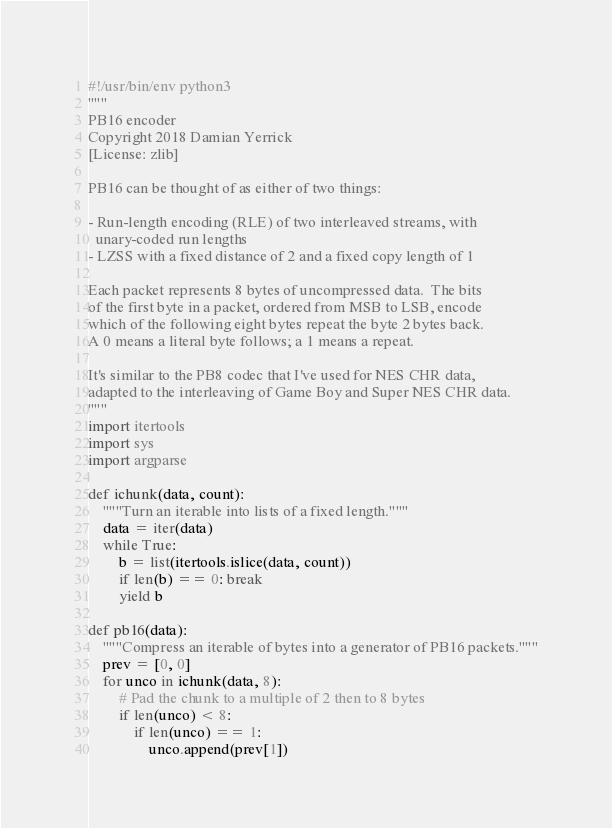<code> <loc_0><loc_0><loc_500><loc_500><_Python_>#!/usr/bin/env python3
"""
PB16 encoder
Copyright 2018 Damian Yerrick
[License: zlib]

PB16 can be thought of as either of two things:

- Run-length encoding (RLE) of two interleaved streams, with
  unary-coded run lengths
- LZSS with a fixed distance of 2 and a fixed copy length of 1

Each packet represents 8 bytes of uncompressed data.  The bits
of the first byte in a packet, ordered from MSB to LSB, encode
which of the following eight bytes repeat the byte 2 bytes back.
A 0 means a literal byte follows; a 1 means a repeat.

It's similar to the PB8 codec that I've used for NES CHR data,
adapted to the interleaving of Game Boy and Super NES CHR data.
"""
import itertools
import sys
import argparse

def ichunk(data, count):
    """Turn an iterable into lists of a fixed length."""
    data = iter(data)
    while True:
        b = list(itertools.islice(data, count))
        if len(b) == 0: break
        yield b

def pb16(data):
    """Compress an iterable of bytes into a generator of PB16 packets."""
    prev = [0, 0]
    for unco in ichunk(data, 8):
        # Pad the chunk to a multiple of 2 then to 8 bytes
        if len(unco) < 8:
            if len(unco) == 1:
                unco.append(prev[1])</code> 